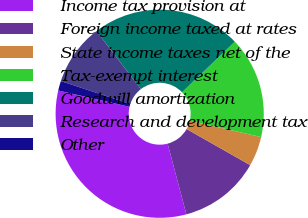Convert chart. <chart><loc_0><loc_0><loc_500><loc_500><pie_chart><fcel>Income tax provision at<fcel>Foreign income taxed at rates<fcel>State income taxes net of the<fcel>Tax-exempt interest<fcel>Goodwill amortization<fcel>Research and development tax<fcel>Other<nl><fcel>32.71%<fcel>12.65%<fcel>4.62%<fcel>15.77%<fcel>23.23%<fcel>9.53%<fcel>1.5%<nl></chart> 